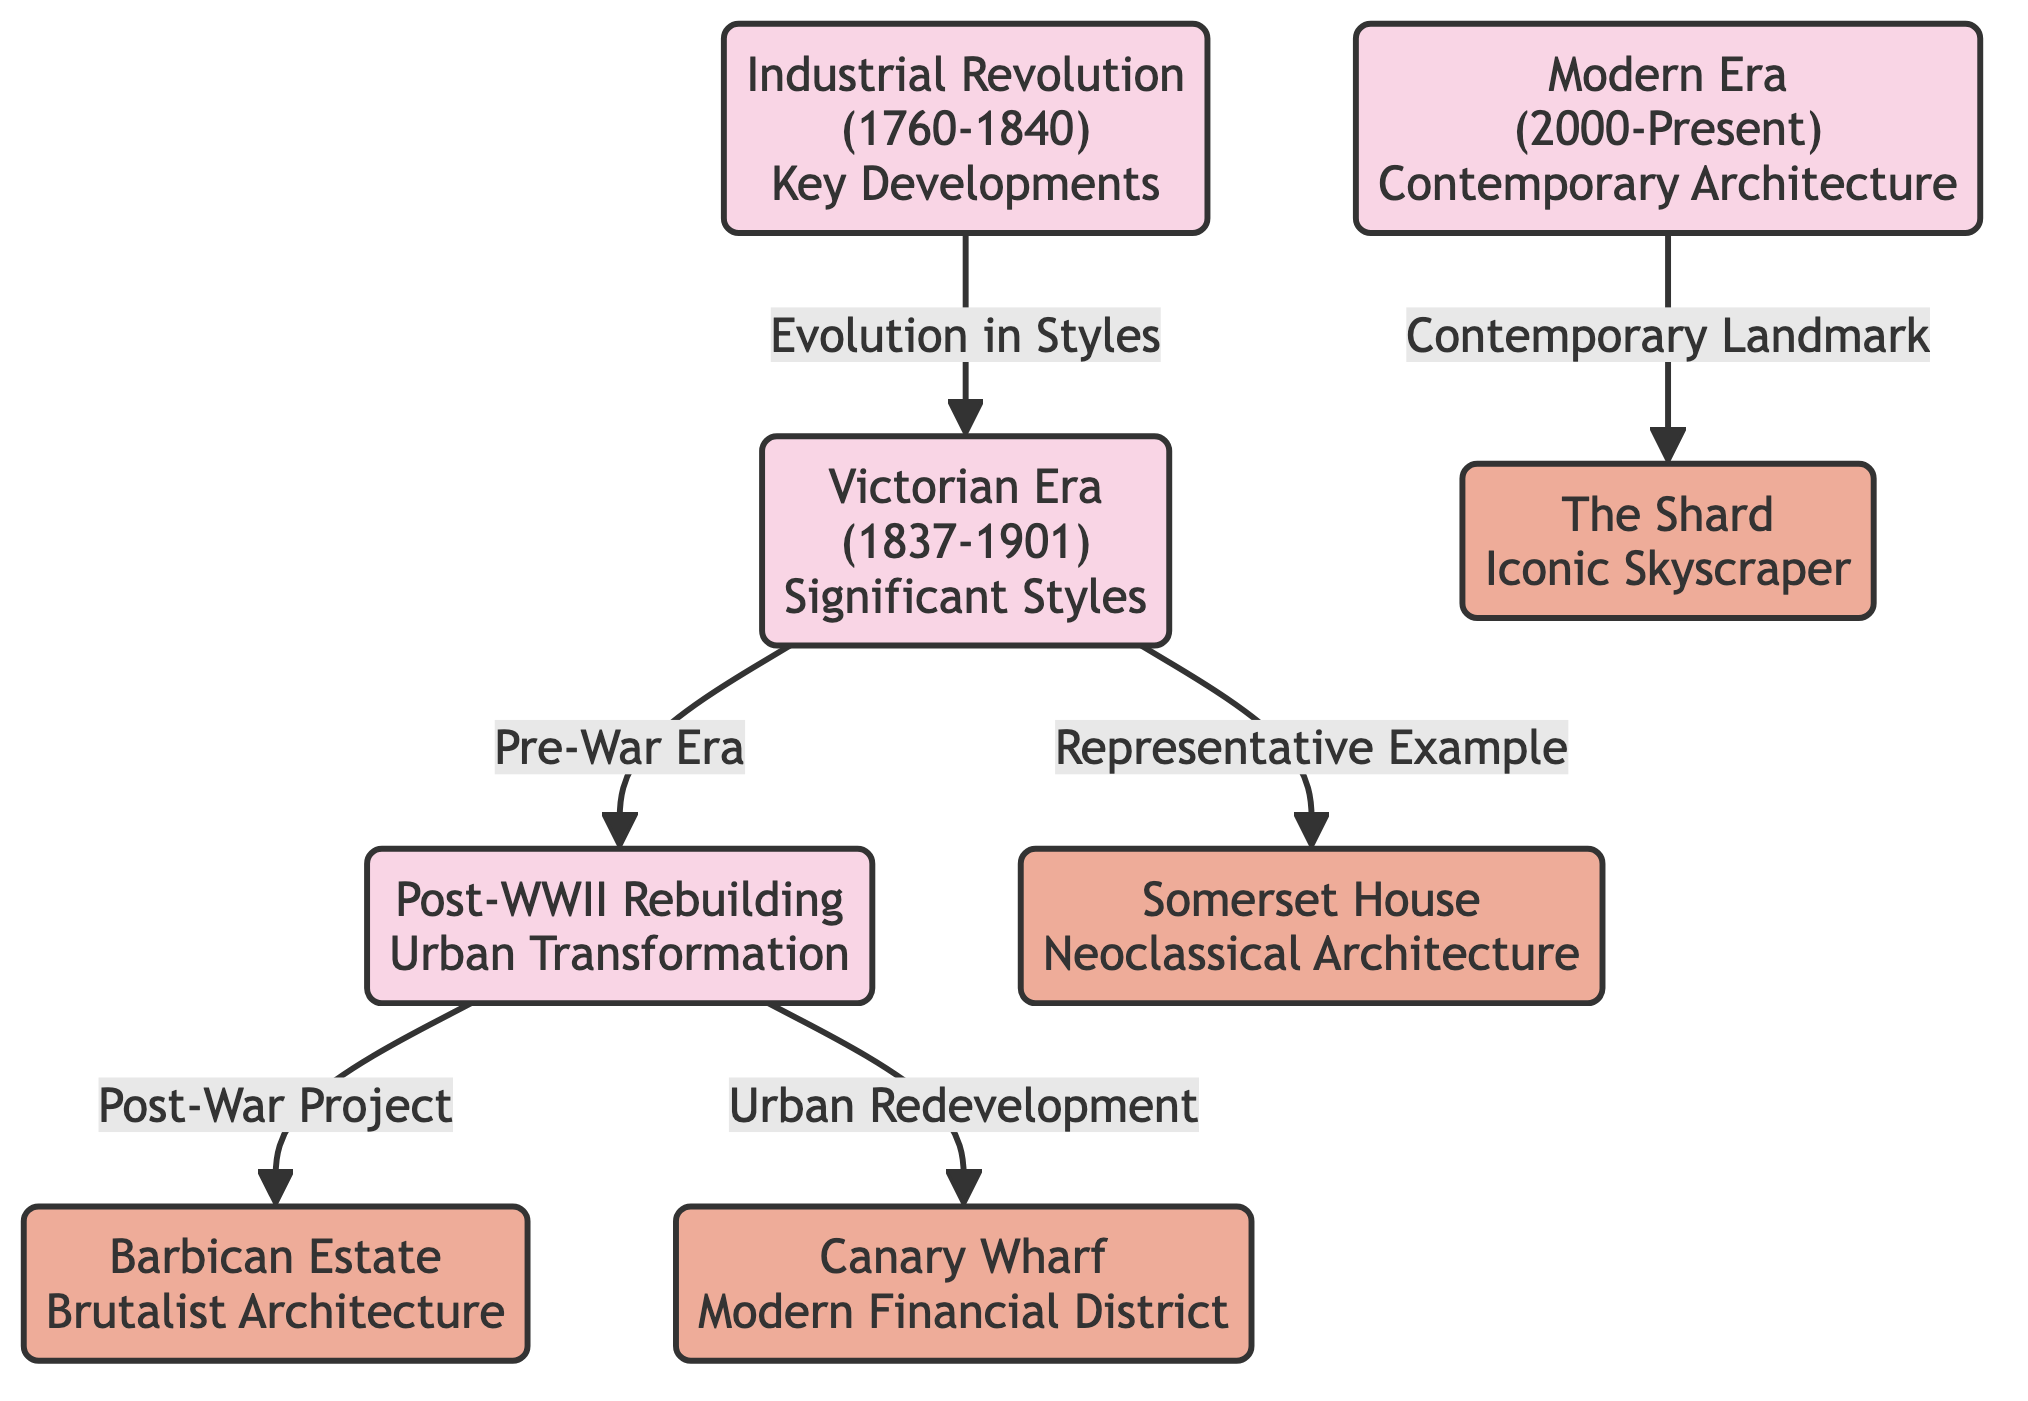What are the main eras of urban architecture depicted in the diagram? The diagram outlines four main eras: Industrial Revolution, Victorian Era, Post-WWII Rebuilding, and Modern Era. Each era is represented as a node in the flowchart, indicating the evolution of urban architecture over time.
Answer: Industrial Revolution, Victorian Era, Post-WWII Rebuilding, Modern Era Which landmark is associated with the Victorian Era? The diagram links the Victorian Era to Somerset House as a representative example. This connection is depicted with a directional arrow indicating the relationship between the two.
Answer: Somerset House What type of architecture is the Barbican Estate known for? The diagram specifies that the Barbican Estate is known for Brutalist Architecture, highlighted as a notable landmark connected to the urban transformation following WWII. The phrase "Brutalist Architecture" is directly associated with the Barbican Estate node.
Answer: Brutalist Architecture How many key developments are shown in the Industrial Revolution era? The diagram does not explicitly state the number of developments, but we observe that it leads into the next era (Victorian Era) with the label "Evolution in Styles." This indicates a continuous evolution without quantifying specific developments. Since it's the starting point, we can infer one major style evolution leading to Victorian architecture.
Answer: 1 What is the key theme connecting the modern era to its landmark? The diagram shows that the connection between the Modern Era and The Shard is defined by the label "Contemporary Landmark." This explains the relationship clearly and emphasizes the importance of The Shard as a modern architectural achievement.
Answer: Contemporary Landmark What significant change occurred during Post-WWII Rebuilding according to the diagram? The diagram illustrates that Post-WWII Rebuilding was associated with urban transformation, as denoted by the arrow leading to landmarks like Barbican Estate and Canary Wharf, indicating the nature of rebuilding efforts during this period.
Answer: Urban Transformation Which era directly precedes the Modern Era? Tracing the directional arrows in the diagram reveals that the Modern Era follows the Post-WWII Rebuilding era, demonstrating a consecutive timeline in the evolution of urban architecture.
Answer: Post-WWII Rebuilding How is Canary Wharf described in the context of the diagram? In the diagram, Canary Wharf is labeled as a "Modern Financial District," which encapsulates its role within the overarching theme of urban redevelopment post-WWII. This description is connected to the corresponding era node through an arrow.
Answer: Modern Financial District What architectural style is notably referenced in the Victorian era? The diagram indicates that the Victorian Era links to significant styles represented broadly, but specifically to Somerset House, which exemplifies neoclassical architectural styles during that period. Therefore, neoclassical is a notable style from this era.
Answer: Neoclassical 